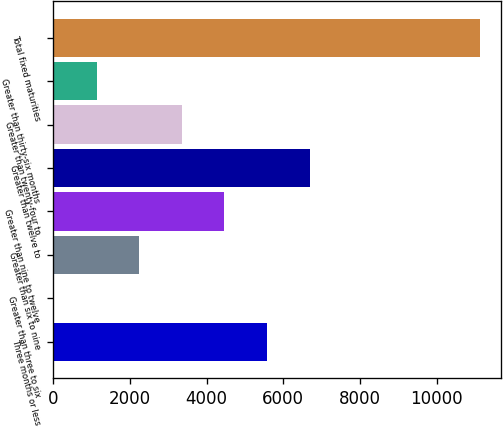Convert chart to OTSL. <chart><loc_0><loc_0><loc_500><loc_500><bar_chart><fcel>Three months or less<fcel>Greater than three to six<fcel>Greater than six to nine<fcel>Greater than nine to twelve<fcel>Greater than twelve to<fcel>Greater than twenty-four to<fcel>Greater than thirty-six months<fcel>Total fixed maturities<nl><fcel>5576.1<fcel>30.3<fcel>2248.62<fcel>4466.94<fcel>6685.26<fcel>3357.78<fcel>1139.46<fcel>11121.9<nl></chart> 